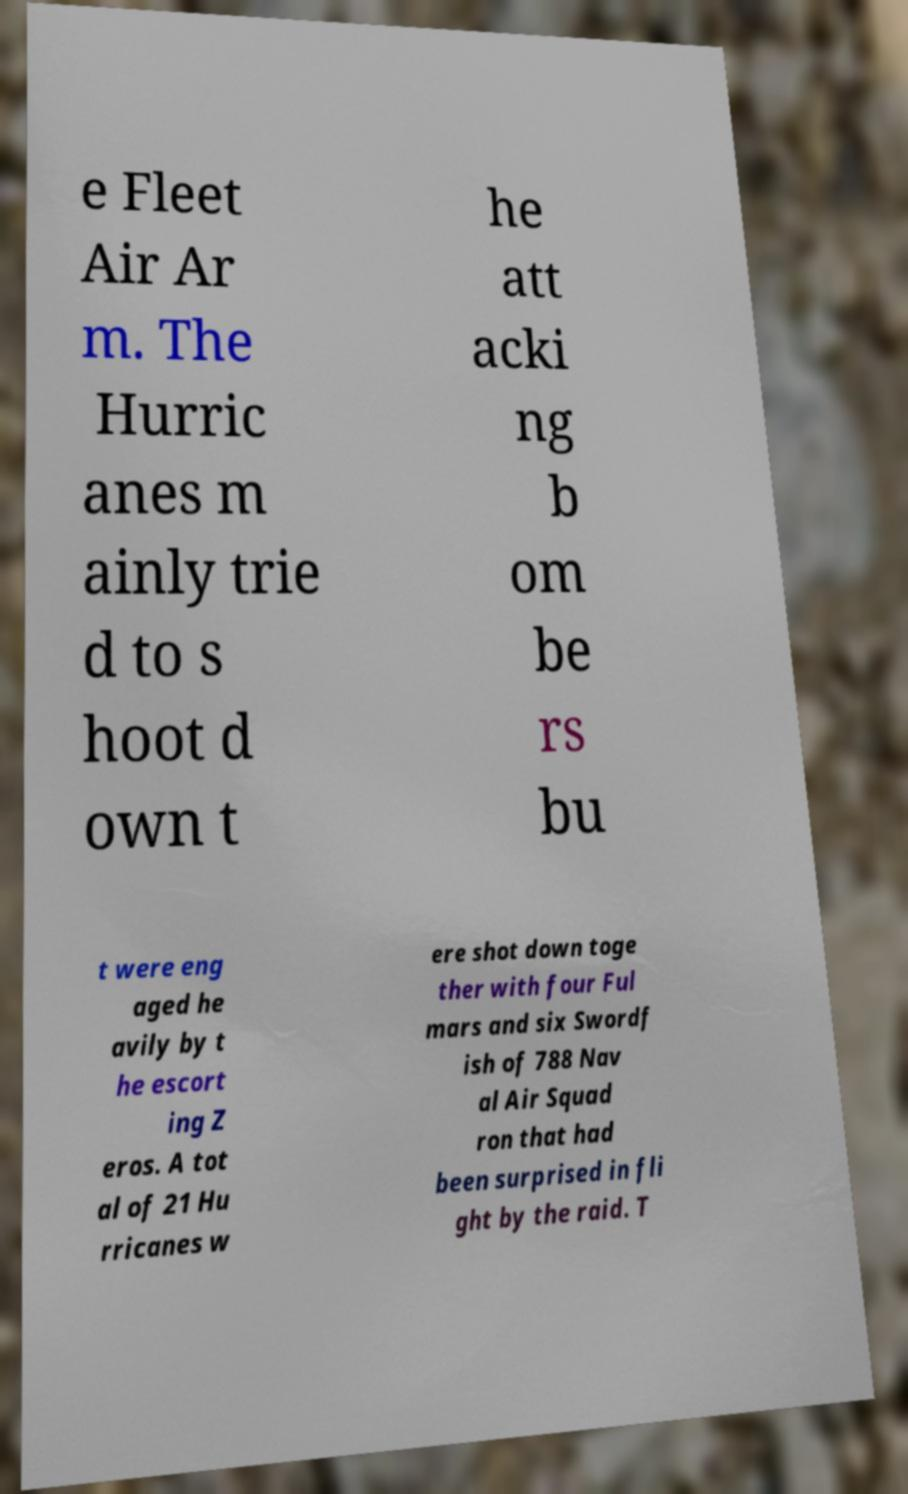There's text embedded in this image that I need extracted. Can you transcribe it verbatim? e Fleet Air Ar m. The Hurric anes m ainly trie d to s hoot d own t he att acki ng b om be rs bu t were eng aged he avily by t he escort ing Z eros. A tot al of 21 Hu rricanes w ere shot down toge ther with four Ful mars and six Swordf ish of 788 Nav al Air Squad ron that had been surprised in fli ght by the raid. T 